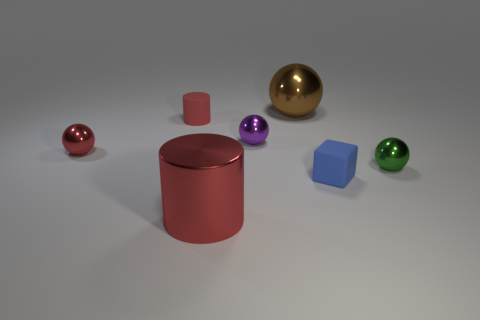What is the size of the other cylinder that is the same color as the matte cylinder?
Give a very brief answer. Large. How many things are either big red metallic cylinders or balls behind the tiny green metal thing?
Offer a terse response. 4. The block has what color?
Make the answer very short. Blue. The big metal object in front of the tiny green metal sphere is what color?
Provide a succinct answer. Red. How many matte things are in front of the tiny sphere right of the tiny blue rubber block?
Provide a short and direct response. 1. Do the red matte cylinder and the object in front of the blue thing have the same size?
Give a very brief answer. No. Is there a red object of the same size as the brown sphere?
Provide a succinct answer. Yes. How many objects are big blue rubber objects or tiny matte things?
Offer a terse response. 2. Does the shiny object in front of the small block have the same size as the brown shiny thing to the left of the tiny cube?
Your answer should be compact. Yes. Are there any large red matte objects that have the same shape as the brown object?
Your answer should be very brief. No. 